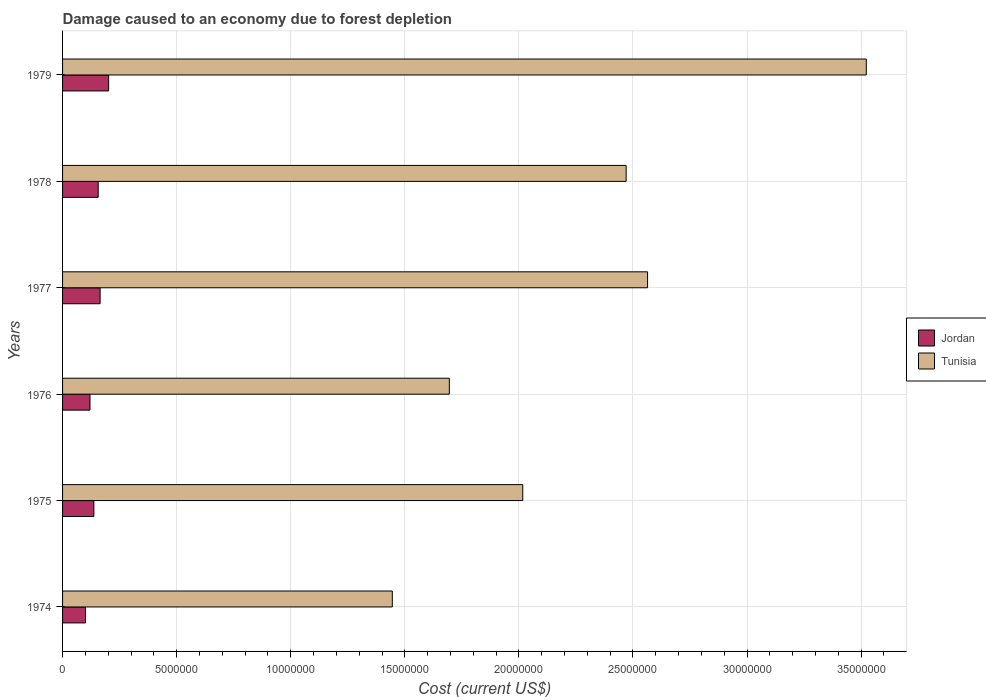How many different coloured bars are there?
Keep it short and to the point. 2. Are the number of bars per tick equal to the number of legend labels?
Provide a short and direct response. Yes. Are the number of bars on each tick of the Y-axis equal?
Keep it short and to the point. Yes. How many bars are there on the 6th tick from the bottom?
Ensure brevity in your answer.  2. What is the cost of damage caused due to forest depletion in Jordan in 1977?
Ensure brevity in your answer.  1.65e+06. Across all years, what is the maximum cost of damage caused due to forest depletion in Tunisia?
Offer a very short reply. 3.52e+07. Across all years, what is the minimum cost of damage caused due to forest depletion in Tunisia?
Offer a very short reply. 1.45e+07. In which year was the cost of damage caused due to forest depletion in Jordan maximum?
Your response must be concise. 1979. In which year was the cost of damage caused due to forest depletion in Jordan minimum?
Provide a short and direct response. 1974. What is the total cost of damage caused due to forest depletion in Jordan in the graph?
Offer a terse response. 8.81e+06. What is the difference between the cost of damage caused due to forest depletion in Tunisia in 1975 and that in 1978?
Provide a succinct answer. -4.53e+06. What is the difference between the cost of damage caused due to forest depletion in Tunisia in 1979 and the cost of damage caused due to forest depletion in Jordan in 1976?
Your response must be concise. 3.40e+07. What is the average cost of damage caused due to forest depletion in Jordan per year?
Keep it short and to the point. 1.47e+06. In the year 1979, what is the difference between the cost of damage caused due to forest depletion in Tunisia and cost of damage caused due to forest depletion in Jordan?
Ensure brevity in your answer.  3.32e+07. In how many years, is the cost of damage caused due to forest depletion in Jordan greater than 20000000 US$?
Ensure brevity in your answer.  0. What is the ratio of the cost of damage caused due to forest depletion in Jordan in 1975 to that in 1977?
Make the answer very short. 0.83. Is the cost of damage caused due to forest depletion in Tunisia in 1975 less than that in 1977?
Ensure brevity in your answer.  Yes. Is the difference between the cost of damage caused due to forest depletion in Tunisia in 1977 and 1979 greater than the difference between the cost of damage caused due to forest depletion in Jordan in 1977 and 1979?
Give a very brief answer. No. What is the difference between the highest and the second highest cost of damage caused due to forest depletion in Jordan?
Your answer should be compact. 3.74e+05. What is the difference between the highest and the lowest cost of damage caused due to forest depletion in Jordan?
Provide a short and direct response. 1.01e+06. What does the 1st bar from the top in 1974 represents?
Your answer should be compact. Tunisia. What does the 2nd bar from the bottom in 1974 represents?
Provide a short and direct response. Tunisia. How many bars are there?
Make the answer very short. 12. What is the difference between two consecutive major ticks on the X-axis?
Give a very brief answer. 5.00e+06. Are the values on the major ticks of X-axis written in scientific E-notation?
Ensure brevity in your answer.  No. Does the graph contain any zero values?
Offer a very short reply. No. Does the graph contain grids?
Ensure brevity in your answer.  Yes. Where does the legend appear in the graph?
Make the answer very short. Center right. What is the title of the graph?
Offer a very short reply. Damage caused to an economy due to forest depletion. What is the label or title of the X-axis?
Your answer should be compact. Cost (current US$). What is the label or title of the Y-axis?
Offer a terse response. Years. What is the Cost (current US$) in Jordan in 1974?
Make the answer very short. 1.01e+06. What is the Cost (current US$) of Tunisia in 1974?
Your answer should be compact. 1.45e+07. What is the Cost (current US$) of Jordan in 1975?
Offer a very short reply. 1.37e+06. What is the Cost (current US$) of Tunisia in 1975?
Provide a succinct answer. 2.02e+07. What is the Cost (current US$) of Jordan in 1976?
Your answer should be very brief. 1.20e+06. What is the Cost (current US$) in Tunisia in 1976?
Keep it short and to the point. 1.70e+07. What is the Cost (current US$) of Jordan in 1977?
Ensure brevity in your answer.  1.65e+06. What is the Cost (current US$) in Tunisia in 1977?
Keep it short and to the point. 2.56e+07. What is the Cost (current US$) in Jordan in 1978?
Offer a terse response. 1.56e+06. What is the Cost (current US$) of Tunisia in 1978?
Offer a terse response. 2.47e+07. What is the Cost (current US$) of Jordan in 1979?
Give a very brief answer. 2.02e+06. What is the Cost (current US$) of Tunisia in 1979?
Your answer should be compact. 3.52e+07. Across all years, what is the maximum Cost (current US$) in Jordan?
Your answer should be very brief. 2.02e+06. Across all years, what is the maximum Cost (current US$) in Tunisia?
Ensure brevity in your answer.  3.52e+07. Across all years, what is the minimum Cost (current US$) of Jordan?
Offer a terse response. 1.01e+06. Across all years, what is the minimum Cost (current US$) in Tunisia?
Your answer should be very brief. 1.45e+07. What is the total Cost (current US$) of Jordan in the graph?
Your answer should be very brief. 8.81e+06. What is the total Cost (current US$) in Tunisia in the graph?
Your response must be concise. 1.37e+08. What is the difference between the Cost (current US$) of Jordan in 1974 and that in 1975?
Your answer should be very brief. -3.66e+05. What is the difference between the Cost (current US$) of Tunisia in 1974 and that in 1975?
Your answer should be very brief. -5.72e+06. What is the difference between the Cost (current US$) in Jordan in 1974 and that in 1976?
Give a very brief answer. -1.96e+05. What is the difference between the Cost (current US$) of Tunisia in 1974 and that in 1976?
Offer a terse response. -2.50e+06. What is the difference between the Cost (current US$) in Jordan in 1974 and that in 1977?
Your response must be concise. -6.40e+05. What is the difference between the Cost (current US$) in Tunisia in 1974 and that in 1977?
Provide a short and direct response. -1.12e+07. What is the difference between the Cost (current US$) in Jordan in 1974 and that in 1978?
Your answer should be very brief. -5.56e+05. What is the difference between the Cost (current US$) in Tunisia in 1974 and that in 1978?
Give a very brief answer. -1.02e+07. What is the difference between the Cost (current US$) of Jordan in 1974 and that in 1979?
Your answer should be very brief. -1.01e+06. What is the difference between the Cost (current US$) of Tunisia in 1974 and that in 1979?
Offer a terse response. -2.08e+07. What is the difference between the Cost (current US$) in Jordan in 1975 and that in 1976?
Offer a very short reply. 1.70e+05. What is the difference between the Cost (current US$) in Tunisia in 1975 and that in 1976?
Offer a very short reply. 3.22e+06. What is the difference between the Cost (current US$) in Jordan in 1975 and that in 1977?
Your answer should be very brief. -2.74e+05. What is the difference between the Cost (current US$) of Tunisia in 1975 and that in 1977?
Ensure brevity in your answer.  -5.47e+06. What is the difference between the Cost (current US$) in Jordan in 1975 and that in 1978?
Your answer should be very brief. -1.90e+05. What is the difference between the Cost (current US$) of Tunisia in 1975 and that in 1978?
Your answer should be compact. -4.53e+06. What is the difference between the Cost (current US$) in Jordan in 1975 and that in 1979?
Give a very brief answer. -6.48e+05. What is the difference between the Cost (current US$) in Tunisia in 1975 and that in 1979?
Provide a succinct answer. -1.51e+07. What is the difference between the Cost (current US$) of Jordan in 1976 and that in 1977?
Your answer should be very brief. -4.44e+05. What is the difference between the Cost (current US$) in Tunisia in 1976 and that in 1977?
Your answer should be very brief. -8.69e+06. What is the difference between the Cost (current US$) of Jordan in 1976 and that in 1978?
Your answer should be compact. -3.60e+05. What is the difference between the Cost (current US$) of Tunisia in 1976 and that in 1978?
Provide a short and direct response. -7.75e+06. What is the difference between the Cost (current US$) in Jordan in 1976 and that in 1979?
Give a very brief answer. -8.18e+05. What is the difference between the Cost (current US$) of Tunisia in 1976 and that in 1979?
Provide a succinct answer. -1.83e+07. What is the difference between the Cost (current US$) of Jordan in 1977 and that in 1978?
Your answer should be very brief. 8.35e+04. What is the difference between the Cost (current US$) in Tunisia in 1977 and that in 1978?
Provide a succinct answer. 9.39e+05. What is the difference between the Cost (current US$) of Jordan in 1977 and that in 1979?
Provide a succinct answer. -3.74e+05. What is the difference between the Cost (current US$) of Tunisia in 1977 and that in 1979?
Provide a short and direct response. -9.59e+06. What is the difference between the Cost (current US$) of Jordan in 1978 and that in 1979?
Provide a short and direct response. -4.58e+05. What is the difference between the Cost (current US$) in Tunisia in 1978 and that in 1979?
Your answer should be compact. -1.05e+07. What is the difference between the Cost (current US$) of Jordan in 1974 and the Cost (current US$) of Tunisia in 1975?
Your answer should be compact. -1.92e+07. What is the difference between the Cost (current US$) of Jordan in 1974 and the Cost (current US$) of Tunisia in 1976?
Offer a very short reply. -1.59e+07. What is the difference between the Cost (current US$) in Jordan in 1974 and the Cost (current US$) in Tunisia in 1977?
Ensure brevity in your answer.  -2.46e+07. What is the difference between the Cost (current US$) of Jordan in 1974 and the Cost (current US$) of Tunisia in 1978?
Provide a short and direct response. -2.37e+07. What is the difference between the Cost (current US$) of Jordan in 1974 and the Cost (current US$) of Tunisia in 1979?
Ensure brevity in your answer.  -3.42e+07. What is the difference between the Cost (current US$) of Jordan in 1975 and the Cost (current US$) of Tunisia in 1976?
Give a very brief answer. -1.56e+07. What is the difference between the Cost (current US$) in Jordan in 1975 and the Cost (current US$) in Tunisia in 1977?
Provide a succinct answer. -2.43e+07. What is the difference between the Cost (current US$) in Jordan in 1975 and the Cost (current US$) in Tunisia in 1978?
Ensure brevity in your answer.  -2.33e+07. What is the difference between the Cost (current US$) in Jordan in 1975 and the Cost (current US$) in Tunisia in 1979?
Offer a very short reply. -3.39e+07. What is the difference between the Cost (current US$) of Jordan in 1976 and the Cost (current US$) of Tunisia in 1977?
Your response must be concise. -2.44e+07. What is the difference between the Cost (current US$) in Jordan in 1976 and the Cost (current US$) in Tunisia in 1978?
Provide a short and direct response. -2.35e+07. What is the difference between the Cost (current US$) in Jordan in 1976 and the Cost (current US$) in Tunisia in 1979?
Offer a terse response. -3.40e+07. What is the difference between the Cost (current US$) in Jordan in 1977 and the Cost (current US$) in Tunisia in 1978?
Your response must be concise. -2.31e+07. What is the difference between the Cost (current US$) of Jordan in 1977 and the Cost (current US$) of Tunisia in 1979?
Give a very brief answer. -3.36e+07. What is the difference between the Cost (current US$) of Jordan in 1978 and the Cost (current US$) of Tunisia in 1979?
Make the answer very short. -3.37e+07. What is the average Cost (current US$) in Jordan per year?
Your answer should be compact. 1.47e+06. What is the average Cost (current US$) in Tunisia per year?
Your response must be concise. 2.29e+07. In the year 1974, what is the difference between the Cost (current US$) in Jordan and Cost (current US$) in Tunisia?
Offer a terse response. -1.34e+07. In the year 1975, what is the difference between the Cost (current US$) of Jordan and Cost (current US$) of Tunisia?
Offer a very short reply. -1.88e+07. In the year 1976, what is the difference between the Cost (current US$) in Jordan and Cost (current US$) in Tunisia?
Your answer should be very brief. -1.58e+07. In the year 1977, what is the difference between the Cost (current US$) of Jordan and Cost (current US$) of Tunisia?
Give a very brief answer. -2.40e+07. In the year 1978, what is the difference between the Cost (current US$) of Jordan and Cost (current US$) of Tunisia?
Make the answer very short. -2.31e+07. In the year 1979, what is the difference between the Cost (current US$) in Jordan and Cost (current US$) in Tunisia?
Provide a succinct answer. -3.32e+07. What is the ratio of the Cost (current US$) of Jordan in 1974 to that in 1975?
Your answer should be compact. 0.73. What is the ratio of the Cost (current US$) in Tunisia in 1974 to that in 1975?
Your answer should be compact. 0.72. What is the ratio of the Cost (current US$) in Jordan in 1974 to that in 1976?
Provide a short and direct response. 0.84. What is the ratio of the Cost (current US$) of Tunisia in 1974 to that in 1976?
Your response must be concise. 0.85. What is the ratio of the Cost (current US$) in Jordan in 1974 to that in 1977?
Ensure brevity in your answer.  0.61. What is the ratio of the Cost (current US$) in Tunisia in 1974 to that in 1977?
Your answer should be compact. 0.56. What is the ratio of the Cost (current US$) of Jordan in 1974 to that in 1978?
Make the answer very short. 0.64. What is the ratio of the Cost (current US$) of Tunisia in 1974 to that in 1978?
Keep it short and to the point. 0.59. What is the ratio of the Cost (current US$) of Jordan in 1974 to that in 1979?
Offer a terse response. 0.5. What is the ratio of the Cost (current US$) of Tunisia in 1974 to that in 1979?
Your answer should be compact. 0.41. What is the ratio of the Cost (current US$) in Jordan in 1975 to that in 1976?
Ensure brevity in your answer.  1.14. What is the ratio of the Cost (current US$) of Tunisia in 1975 to that in 1976?
Keep it short and to the point. 1.19. What is the ratio of the Cost (current US$) in Jordan in 1975 to that in 1977?
Your answer should be very brief. 0.83. What is the ratio of the Cost (current US$) in Tunisia in 1975 to that in 1977?
Offer a terse response. 0.79. What is the ratio of the Cost (current US$) of Jordan in 1975 to that in 1978?
Give a very brief answer. 0.88. What is the ratio of the Cost (current US$) of Tunisia in 1975 to that in 1978?
Make the answer very short. 0.82. What is the ratio of the Cost (current US$) in Jordan in 1975 to that in 1979?
Ensure brevity in your answer.  0.68. What is the ratio of the Cost (current US$) of Tunisia in 1975 to that in 1979?
Offer a very short reply. 0.57. What is the ratio of the Cost (current US$) in Jordan in 1976 to that in 1977?
Offer a terse response. 0.73. What is the ratio of the Cost (current US$) in Tunisia in 1976 to that in 1977?
Offer a very short reply. 0.66. What is the ratio of the Cost (current US$) in Jordan in 1976 to that in 1978?
Offer a terse response. 0.77. What is the ratio of the Cost (current US$) of Tunisia in 1976 to that in 1978?
Your response must be concise. 0.69. What is the ratio of the Cost (current US$) of Jordan in 1976 to that in 1979?
Make the answer very short. 0.6. What is the ratio of the Cost (current US$) in Tunisia in 1976 to that in 1979?
Give a very brief answer. 0.48. What is the ratio of the Cost (current US$) of Jordan in 1977 to that in 1978?
Your response must be concise. 1.05. What is the ratio of the Cost (current US$) of Tunisia in 1977 to that in 1978?
Ensure brevity in your answer.  1.04. What is the ratio of the Cost (current US$) in Jordan in 1977 to that in 1979?
Make the answer very short. 0.81. What is the ratio of the Cost (current US$) of Tunisia in 1977 to that in 1979?
Your response must be concise. 0.73. What is the ratio of the Cost (current US$) in Jordan in 1978 to that in 1979?
Ensure brevity in your answer.  0.77. What is the ratio of the Cost (current US$) in Tunisia in 1978 to that in 1979?
Keep it short and to the point. 0.7. What is the difference between the highest and the second highest Cost (current US$) in Jordan?
Offer a very short reply. 3.74e+05. What is the difference between the highest and the second highest Cost (current US$) in Tunisia?
Your answer should be compact. 9.59e+06. What is the difference between the highest and the lowest Cost (current US$) in Jordan?
Make the answer very short. 1.01e+06. What is the difference between the highest and the lowest Cost (current US$) of Tunisia?
Your answer should be compact. 2.08e+07. 